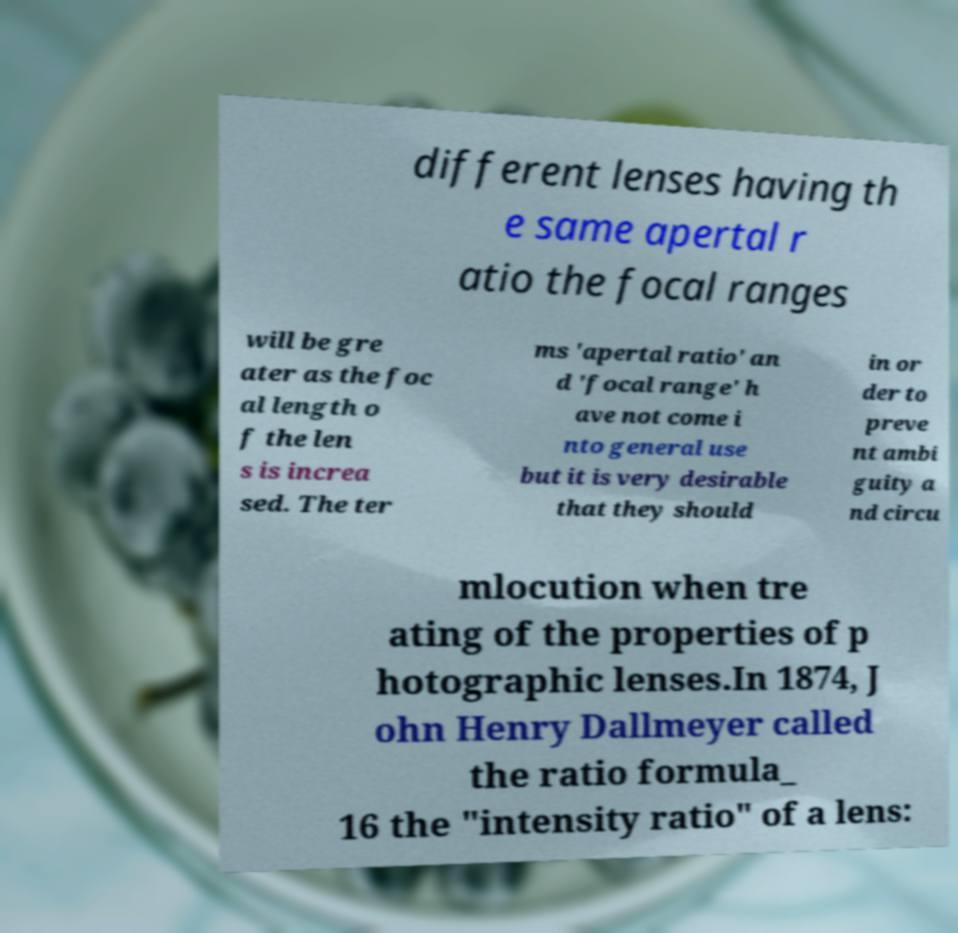Please identify and transcribe the text found in this image. different lenses having th e same apertal r atio the focal ranges will be gre ater as the foc al length o f the len s is increa sed. The ter ms 'apertal ratio' an d 'focal range' h ave not come i nto general use but it is very desirable that they should in or der to preve nt ambi guity a nd circu mlocution when tre ating of the properties of p hotographic lenses.In 1874, J ohn Henry Dallmeyer called the ratio formula_ 16 the "intensity ratio" of a lens: 